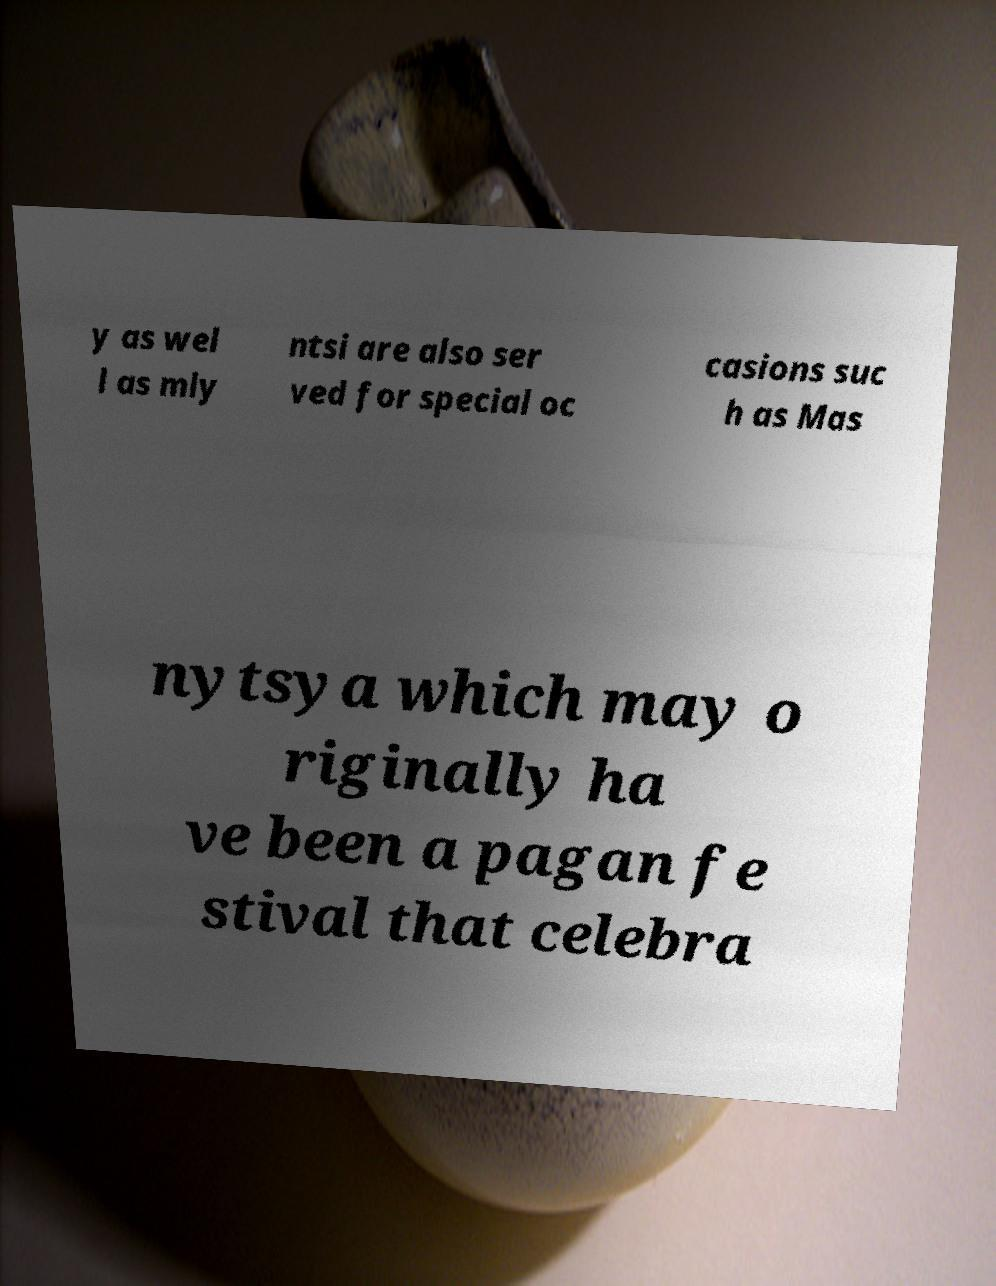For documentation purposes, I need the text within this image transcribed. Could you provide that? y as wel l as mly ntsi are also ser ved for special oc casions suc h as Mas nytsya which may o riginally ha ve been a pagan fe stival that celebra 